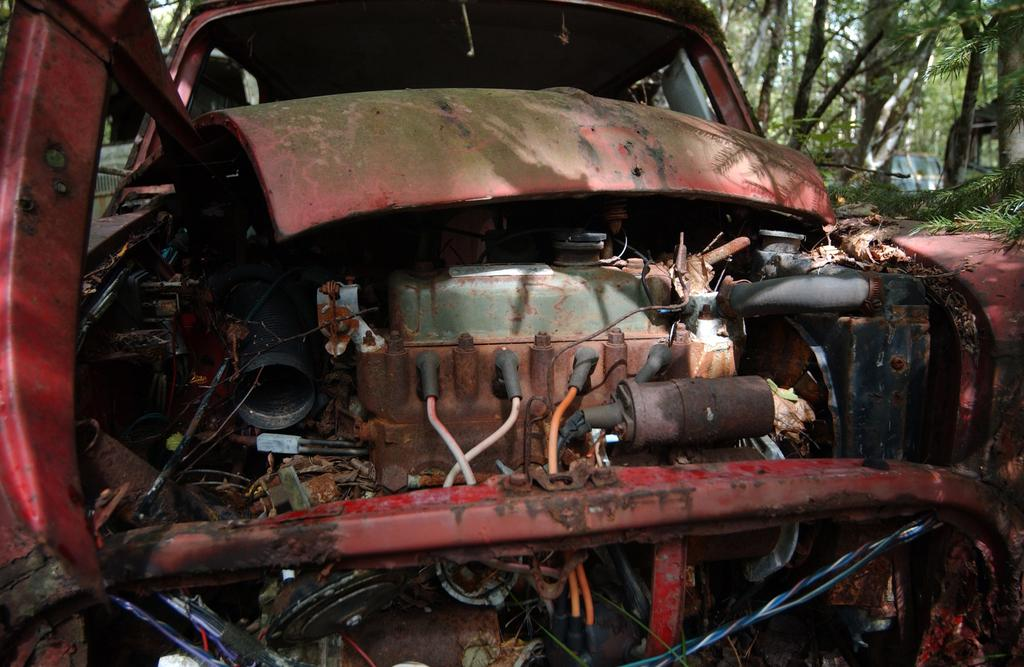What is the main subject of the image? There is a vehicle in the image. What can be seen in addition to the vehicle? There are vehicle parts in the image. What is visible in the background of the image? There are trees in the background of the image. How many frogs are sitting on the vehicle's hood in the image? There are no frogs present in the image. What part of the vehicle is being copied in the image? There is no indication of copying any part of the vehicle in the image. 